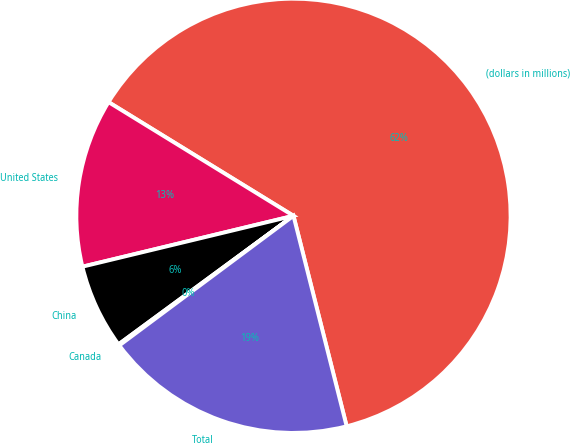Convert chart to OTSL. <chart><loc_0><loc_0><loc_500><loc_500><pie_chart><fcel>(dollars in millions)<fcel>United States<fcel>China<fcel>Canada<fcel>Total<nl><fcel>62.3%<fcel>12.54%<fcel>6.32%<fcel>0.1%<fcel>18.76%<nl></chart> 